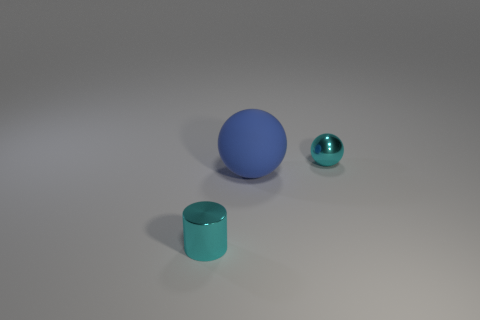How many shiny objects are the same color as the small metal cylinder?
Your answer should be compact. 1. Is there any other thing that has the same size as the blue matte ball?
Your answer should be compact. No. What is the color of the object that is both behind the cyan shiny cylinder and in front of the cyan metal sphere?
Your answer should be very brief. Blue. What is the shape of the small cyan metallic thing that is to the right of the rubber object?
Keep it short and to the point. Sphere. How big is the shiny thing that is behind the metal object that is in front of the small thing that is to the right of the small metallic cylinder?
Provide a succinct answer. Small. There is a cyan object that is left of the matte ball; how many cyan cylinders are on the left side of it?
Give a very brief answer. 0. How big is the thing that is both behind the cyan cylinder and in front of the tiny metal sphere?
Provide a short and direct response. Large. How many rubber things are either cyan objects or big yellow cubes?
Your response must be concise. 0. What is the small cyan sphere made of?
Give a very brief answer. Metal. There is a cyan object in front of the cyan object that is on the right side of the small metal object to the left of the large rubber object; what is its material?
Your answer should be compact. Metal. 